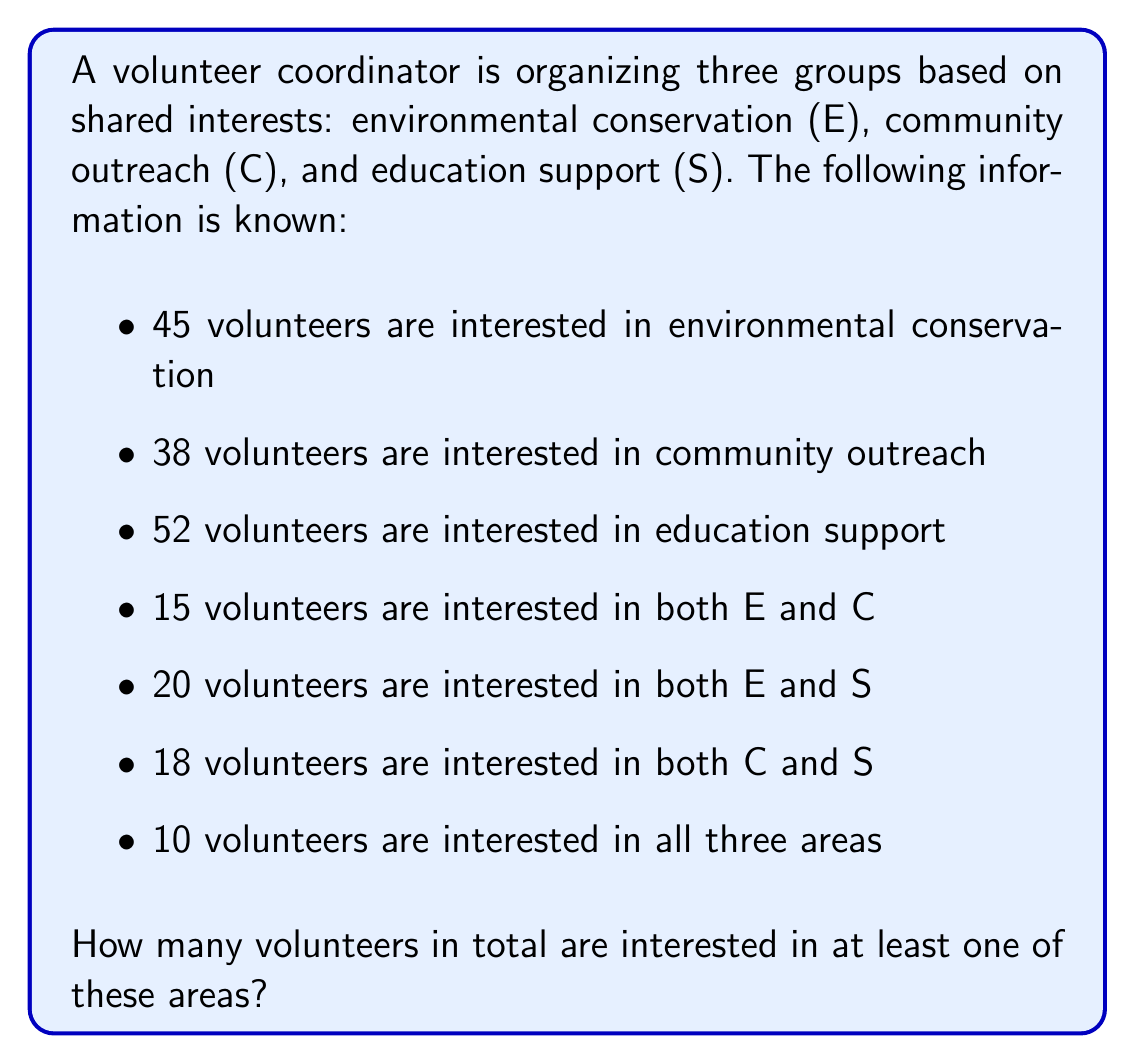Help me with this question. To solve this problem, we can use the principle of inclusion-exclusion for three sets. Let's break it down step-by-step:

1) First, let's define our sets:
   E: Environmental conservation
   C: Community outreach
   S: Education support

2) We're given:
   $|E| = 45$, $|C| = 38$, $|S| = 52$
   $|E \cap C| = 15$, $|E \cap S| = 20$, $|C \cap S| = 18$
   $|E \cap C \cap S| = 10$

3) The principle of inclusion-exclusion for three sets states:

   $$|E \cup C \cup S| = |E| + |C| + |S| - |E \cap C| - |E \cap S| - |C \cap S| + |E \cap C \cap S|$$

4) Let's substitute our known values:

   $$|E \cup C \cup S| = 45 + 38 + 52 - 15 - 20 - 18 + 10$$

5) Now we can calculate:

   $$|E \cup C \cup S| = 135 - 53 + 10 = 92$$

Therefore, the total number of volunteers interested in at least one of these areas is 92.
Answer: 92 volunteers 